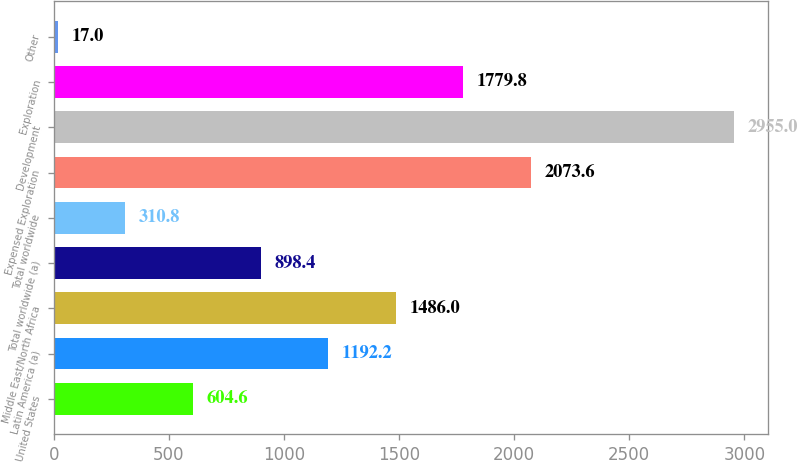Convert chart to OTSL. <chart><loc_0><loc_0><loc_500><loc_500><bar_chart><fcel>United States<fcel>Latin America (a)<fcel>Middle East/North Africa<fcel>Total worldwide (a)<fcel>Total worldwide<fcel>Expensed Exploration<fcel>Development<fcel>Exploration<fcel>Other<nl><fcel>604.6<fcel>1192.2<fcel>1486<fcel>898.4<fcel>310.8<fcel>2073.6<fcel>2955<fcel>1779.8<fcel>17<nl></chart> 